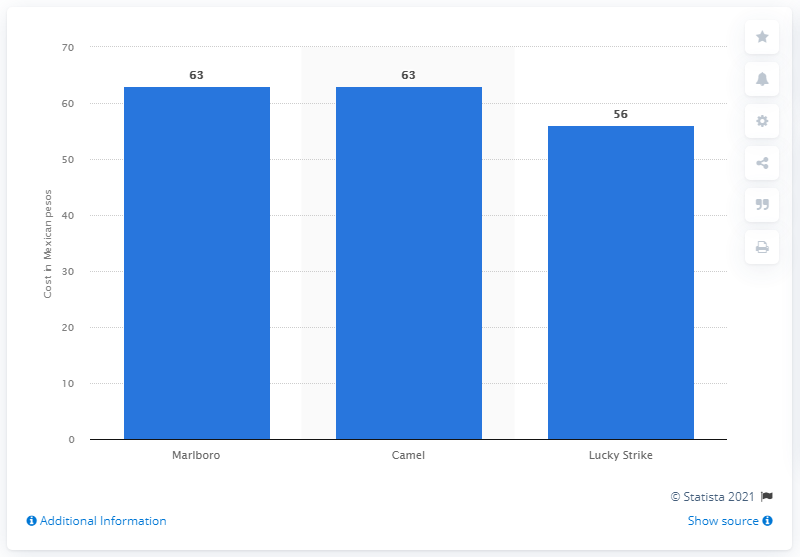Outline some significant characteristics in this image. The cost of a Lucky Strike pack in Mexican pesos was 56. I know the brand of cigarettes that cost 56 Mexican pesos. It is Lucky Strike. In January 2020, the average price of a pack of Marlboro or Camel cigarettes in Mexico was approximately 63 pesos. 